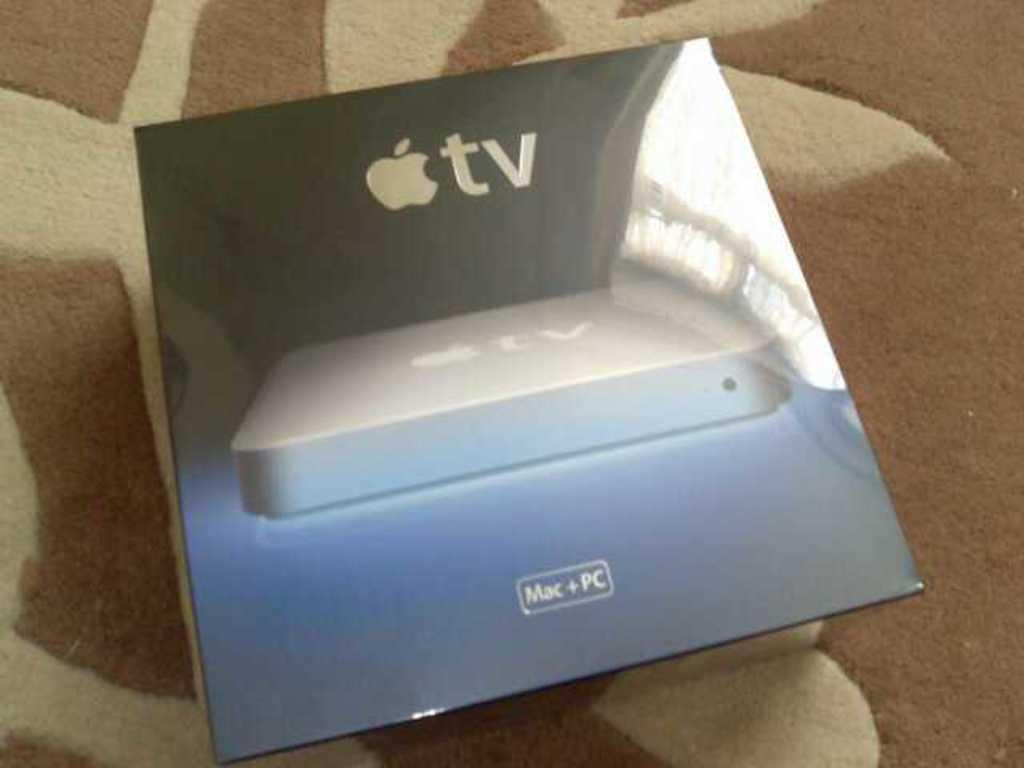<image>
Give a short and clear explanation of the subsequent image. A box has the Apple tv logo and works on Mac and PC. 